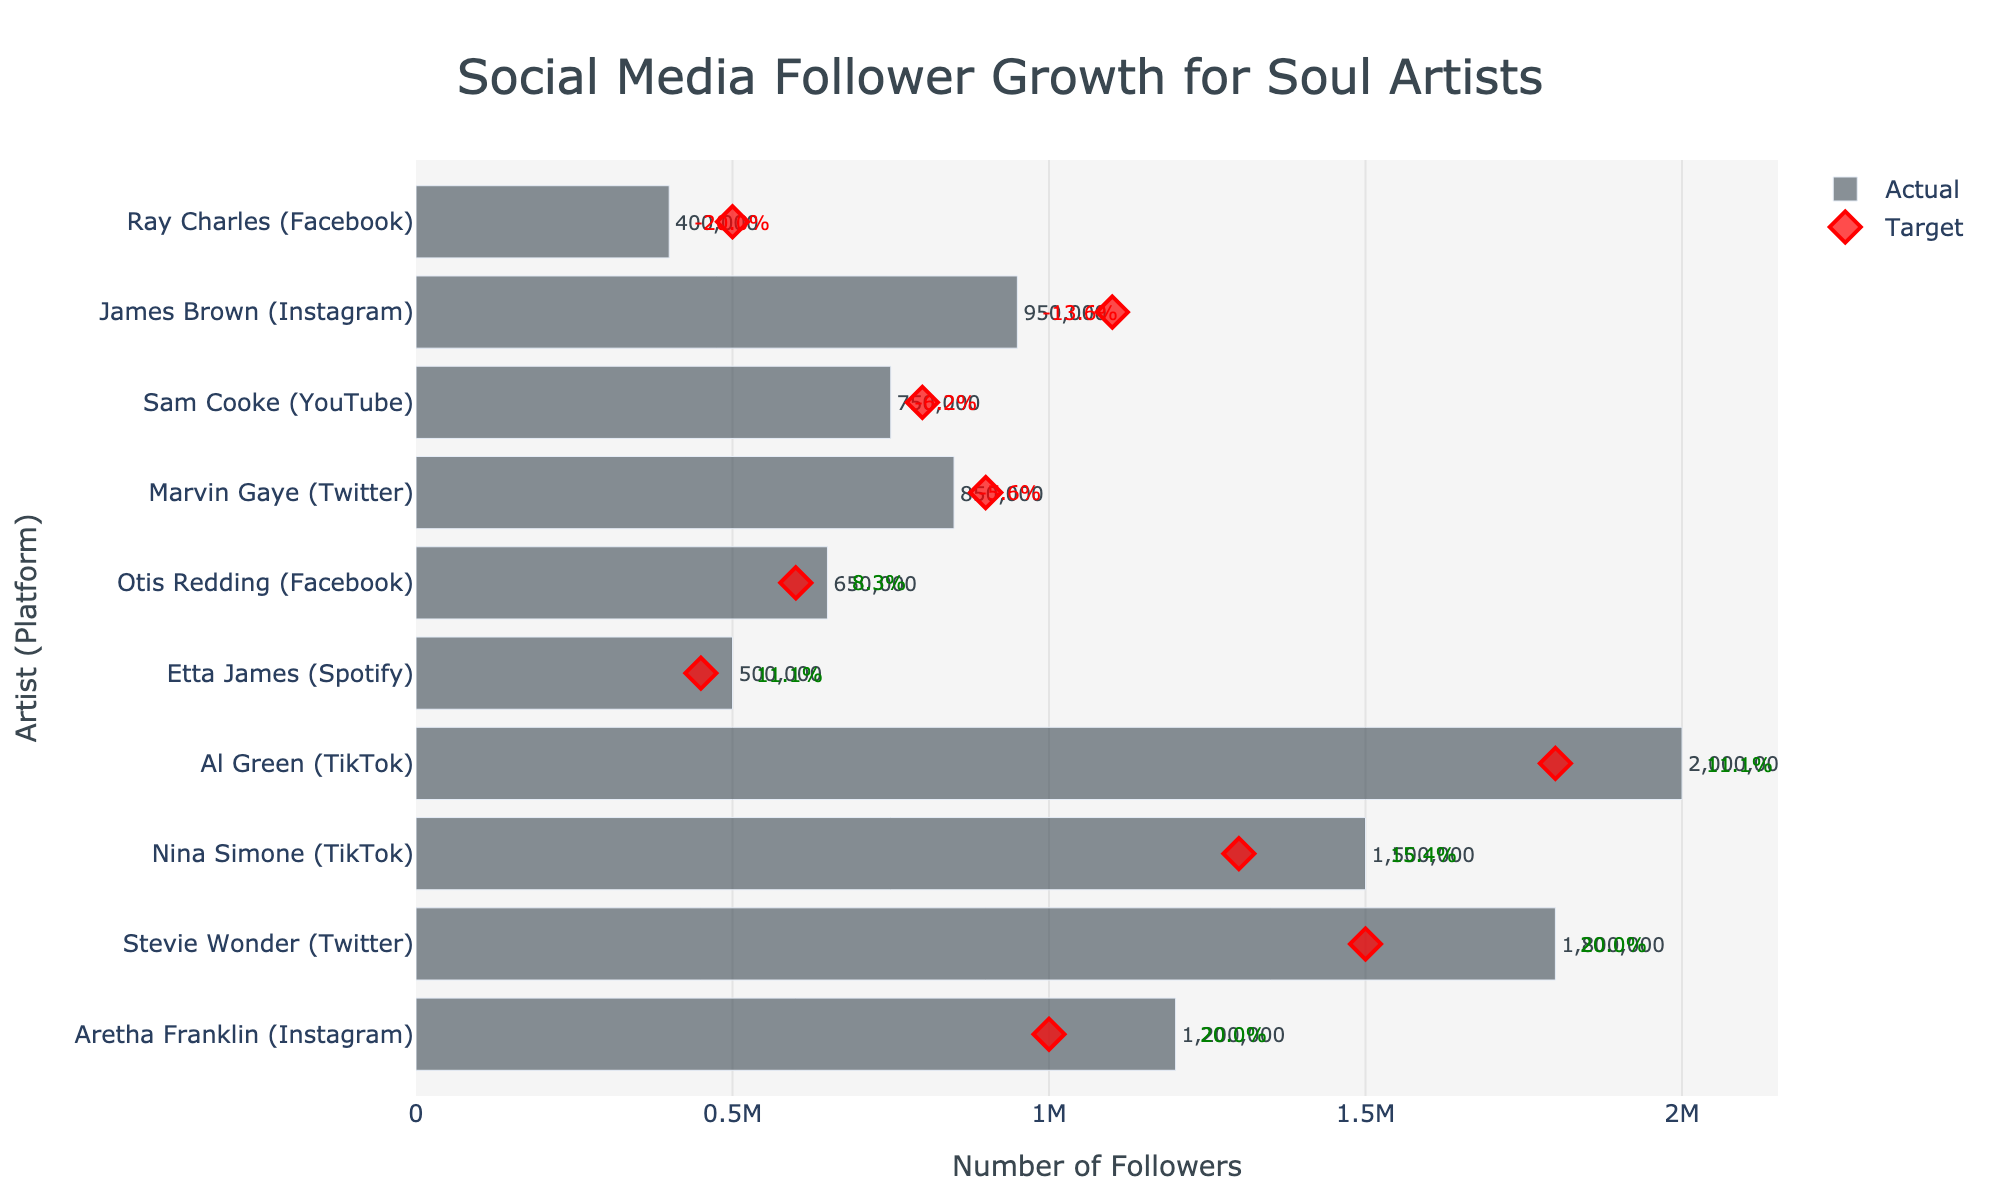What's the title of the chart? To find the title of the chart, observe the top part of the figure where the title is typically positioned.
Answer: Social Media Follower Growth for Soul Artists How many platforms are represented in the data? Look at the different labels on the y-axis which include the platform names next to the artists' names. Count the distinct platforms.
Answer: 5 Which artist has exceeded their target the most on TikTok? Examine TikTok platforms' followers for the artists and compare the actual counts with the target counts.
Answer: Al Green What is Marvin Gaye's actual vs. target follower difference on Twitter? Subtract Marvin Gaye’s target follower count from his actual follower count. Observe Twitter platforms next to Marvin Gaye’s name. Actual: 850,000 and Target: 900,000.
Answer: -50,000 Which artist performs the best on social media overall in terms of actual followers exceeding target followers? Compare the performance percentage of all artists. The artist with the highest positive percentage is the best performer.
Answer: Al Green How does Aretha Franklin's performance on Instagram compare to James Brown's performance on the same platform? Compare the actual and target follower counts of Aretha Franklin and James Brown on Instagram. Look at the percentage difference for both.
Answer: Aretha Franklin performed better How many artists have not met their target follower count? Count how many artists have an actual follower count less than the target follower count by examining the negative performance percentages.
Answer: 3 What is the average actual follower count for artists on Facebook? Sum the actual follower counts of artists on Facebook and divide by the number of artists on Facebook. (Otis Redding: 650,000 + Ray Charles: 400,000) / 2 = 525,000.
Answer: 525,000 Who gained more followers, Sam Cooke on YouTube or Etta James on Spotify? Compare the actual follower counts for Sam Cooke on YouTube and Etta James on Spotify. Sam Cooke: 750,000; Etta James: 500,000.
Answer: Sam Cooke Which artist has the highest performance percentage? Look for the artist with the highest annotation percentage of performance improvement in green.
Answer: Al Green 